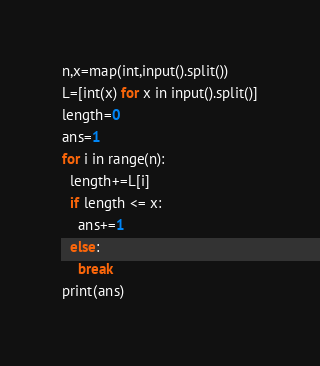<code> <loc_0><loc_0><loc_500><loc_500><_Python_>n,x=map(int,input().split())
L=[int(x) for x in input().split()]
length=0
ans=1
for i in range(n):
  length+=L[i]
  if length <= x:
    ans+=1
  else:
    break
print(ans)</code> 